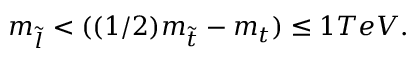<formula> <loc_0><loc_0><loc_500><loc_500>m _ { \tilde { l } } < ( ( 1 / 2 ) m _ { \tilde { t } } - m _ { t } ) \leq 1 T e V .</formula> 